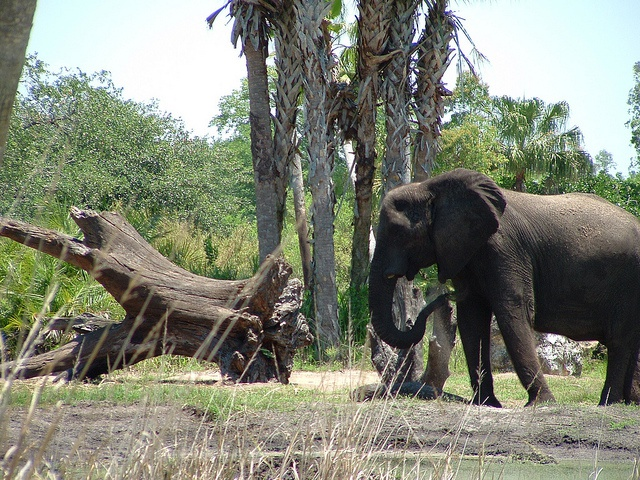Describe the objects in this image and their specific colors. I can see a elephant in darkgreen, black, gray, and darkgray tones in this image. 